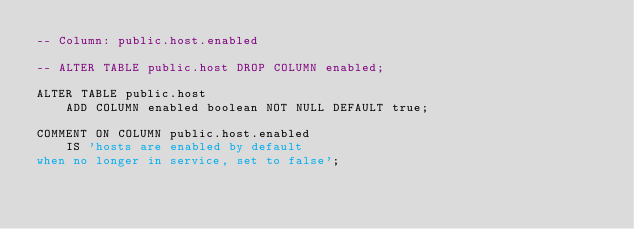<code> <loc_0><loc_0><loc_500><loc_500><_SQL_>-- Column: public.host.enabled

-- ALTER TABLE public.host DROP COLUMN enabled;

ALTER TABLE public.host
    ADD COLUMN enabled boolean NOT NULL DEFAULT true;

COMMENT ON COLUMN public.host.enabled
    IS 'hosts are enabled by default
when no longer in service, set to false';
</code> 